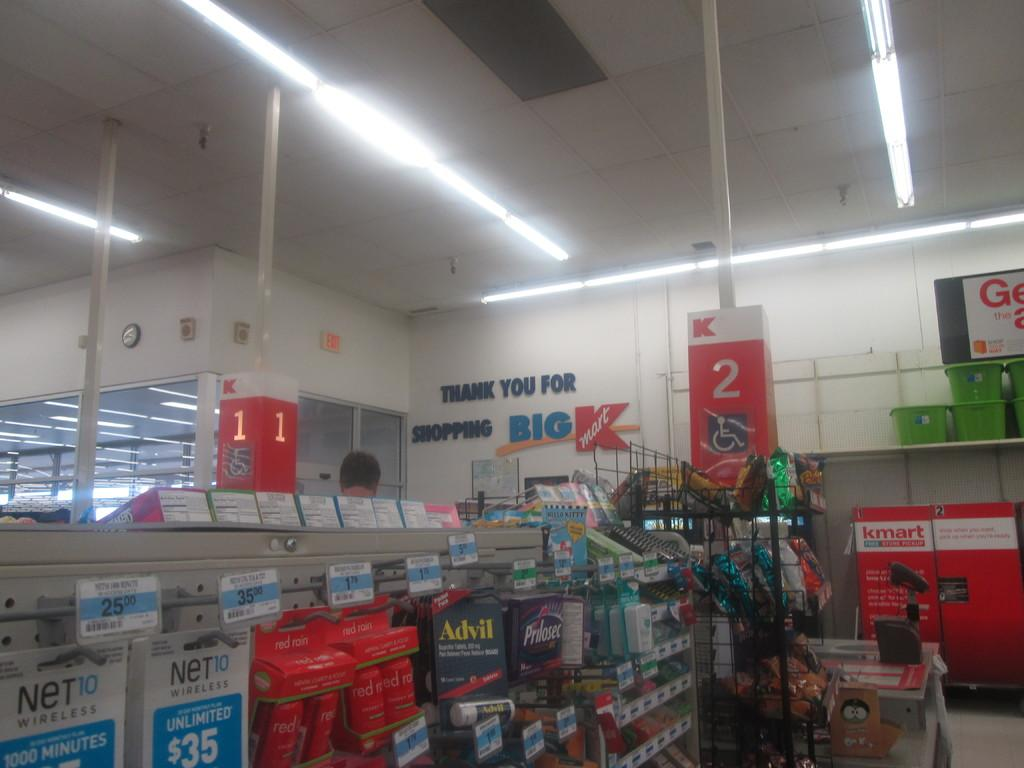<image>
Create a compact narrative representing the image presented. big kmart store display of the inside of store 